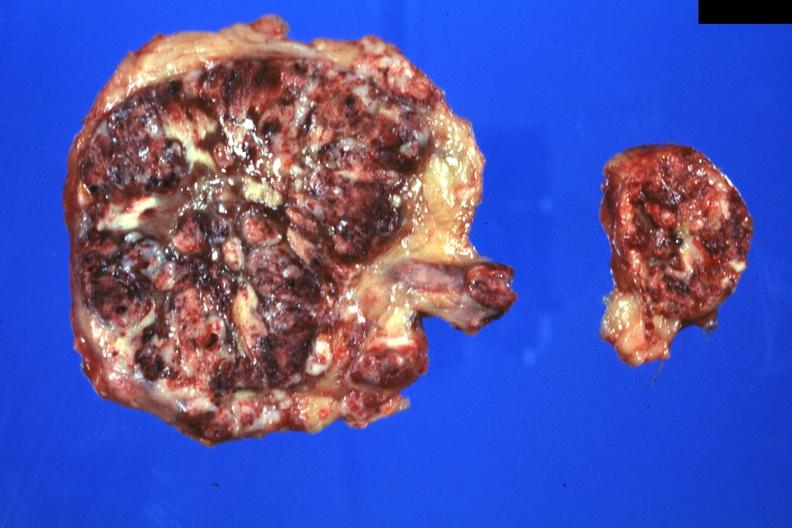s metastatic carcinoma lung present?
Answer the question using a single word or phrase. Yes 